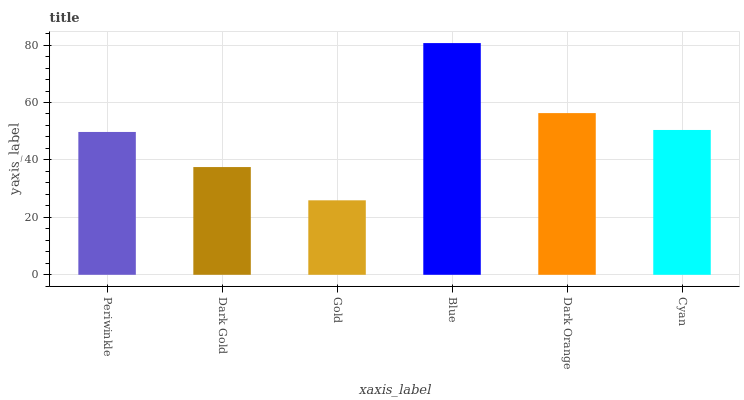Is Gold the minimum?
Answer yes or no. Yes. Is Blue the maximum?
Answer yes or no. Yes. Is Dark Gold the minimum?
Answer yes or no. No. Is Dark Gold the maximum?
Answer yes or no. No. Is Periwinkle greater than Dark Gold?
Answer yes or no. Yes. Is Dark Gold less than Periwinkle?
Answer yes or no. Yes. Is Dark Gold greater than Periwinkle?
Answer yes or no. No. Is Periwinkle less than Dark Gold?
Answer yes or no. No. Is Cyan the high median?
Answer yes or no. Yes. Is Periwinkle the low median?
Answer yes or no. Yes. Is Dark Orange the high median?
Answer yes or no. No. Is Gold the low median?
Answer yes or no. No. 